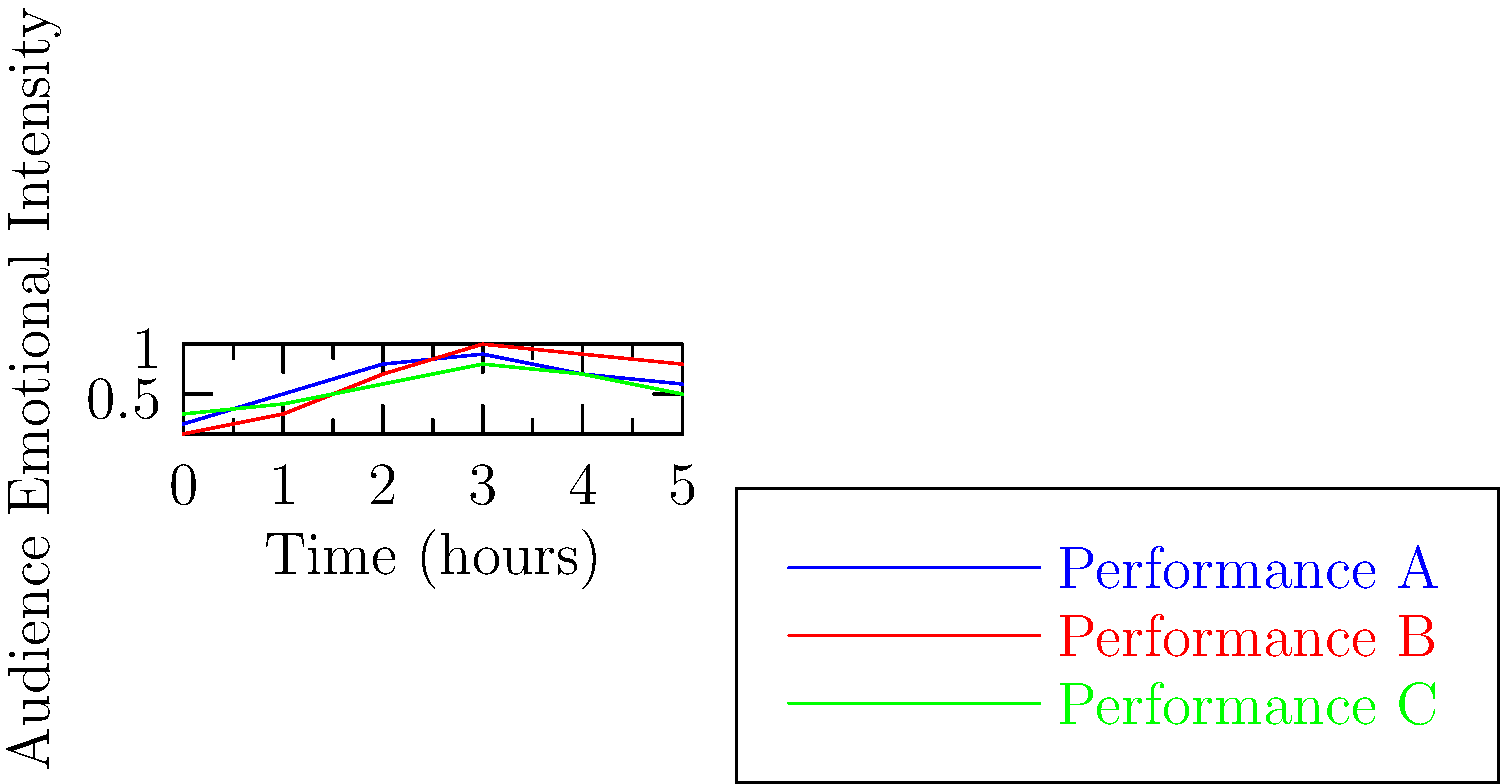Analyze the emotional intensity graph of three theatrical performances over time. Which performance demonstrates the most dramatic build-up and climax, reminiscent of Sarah Ferrati's renowned ability to captivate audiences? Explain your reasoning based on the graph's characteristics. To answer this question, we need to analyze the emotional intensity curves for each performance:

1. Performance A (Blue line):
   - Starts low and gradually increases
   - Reaches its peak around the 3-hour mark
   - Shows a moderate decline afterwards

2. Performance B (Red line):
   - Begins at the lowest point
   - Shows a steep and consistent increase
   - Reaches the highest peak of all performances at the 3-hour mark
   - Maintains a high level of intensity even after the peak

3. Performance C (Green line):
   - Starts at a moderate level
   - Increases gradually but less dramatically than A or B
   - Reaches its peak around the 3-hour mark
   - Shows a moderate decline afterwards

Comparing these patterns:
- Performance B demonstrates the most dramatic build-up, starting from the lowest point and reaching the highest peak.
- The steepness of Performance B's curve indicates a rapid increase in emotional intensity, which is characteristic of a captivating performance.
- The high sustained level after the peak in Performance B suggests a powerful and lasting impact on the audience.

These characteristics align with Sarah Ferrati's renowned ability to captivate audiences, as it shows a performance that builds tension effectively and maintains a strong emotional connection with the audience throughout the show.
Answer: Performance B 